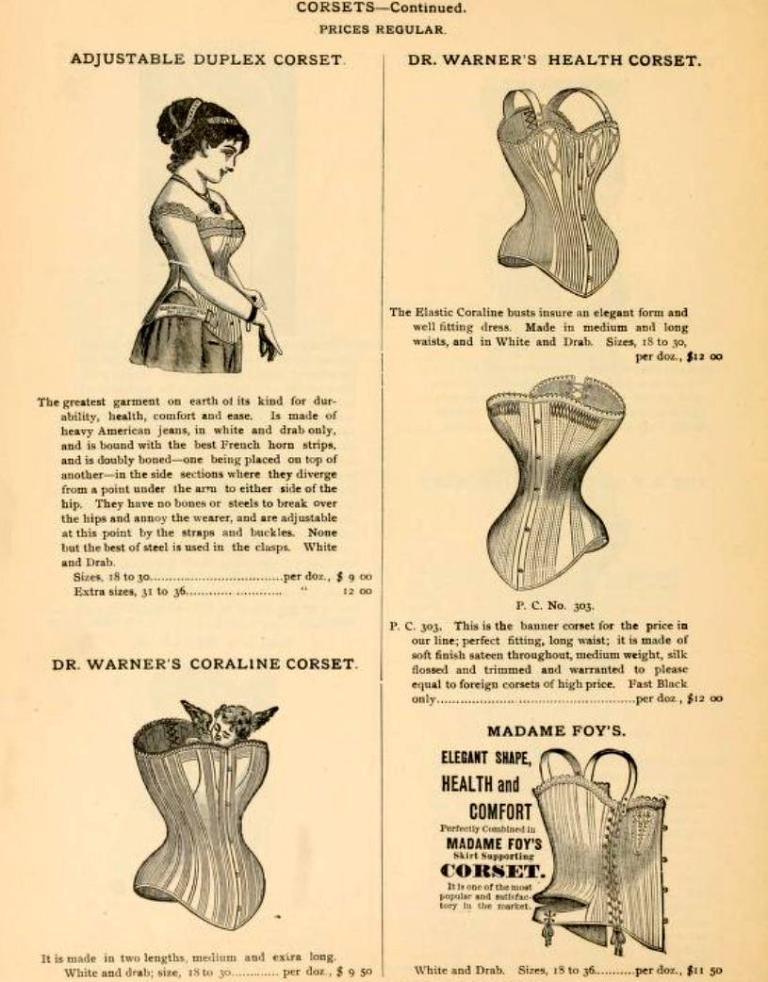What is present on the paper in the image? There is a woman depicted on the paper. What else can be seen on the paper? There is writing on the paper. How many cats are visible in the image? There are no cats present in the image. What is the aftermath of the depicted scene on the paper? The image does not depict a scene with an aftermath; it simply shows a woman and writing on a paper. 